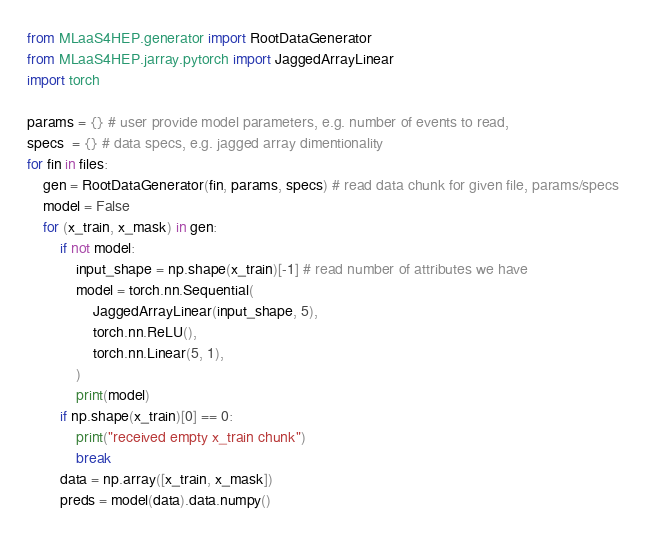Convert code to text. <code><loc_0><loc_0><loc_500><loc_500><_Python_>from MLaaS4HEP.generator import RootDataGenerator
from MLaaS4HEP.jarray.pytorch import JaggedArrayLinear
import torch

params = {} # user provide model parameters, e.g. number of events to read,
specs  = {} # data specs, e.g. jagged array dimentionality
for fin in files:
    gen = RootDataGenerator(fin, params, specs) # read data chunk for given file, params/specs
    model = False
    for (x_train, x_mask) in gen:
        if not model:
            input_shape = np.shape(x_train)[-1] # read number of attributes we have
            model = torch.nn.Sequential(
                JaggedArrayLinear(input_shape, 5),
                torch.nn.ReLU(),
                torch.nn.Linear(5, 1),
            )
            print(model)
        if np.shape(x_train)[0] == 0:
            print("received empty x_train chunk")
            break
        data = np.array([x_train, x_mask])
        preds = model(data).data.numpy()
</code> 